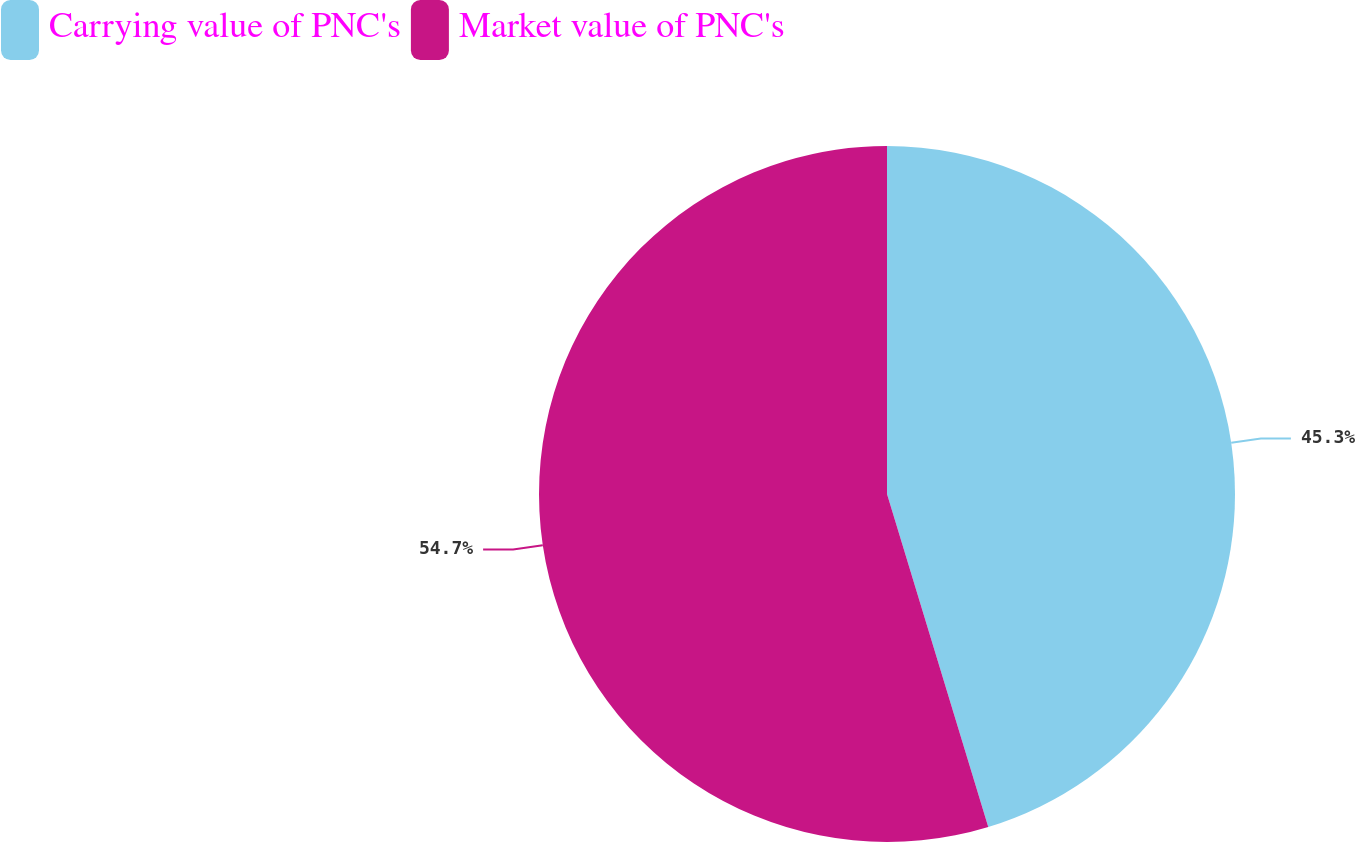<chart> <loc_0><loc_0><loc_500><loc_500><pie_chart><fcel>Carrying value of PNC's<fcel>Market value of PNC's<nl><fcel>45.3%<fcel>54.7%<nl></chart> 